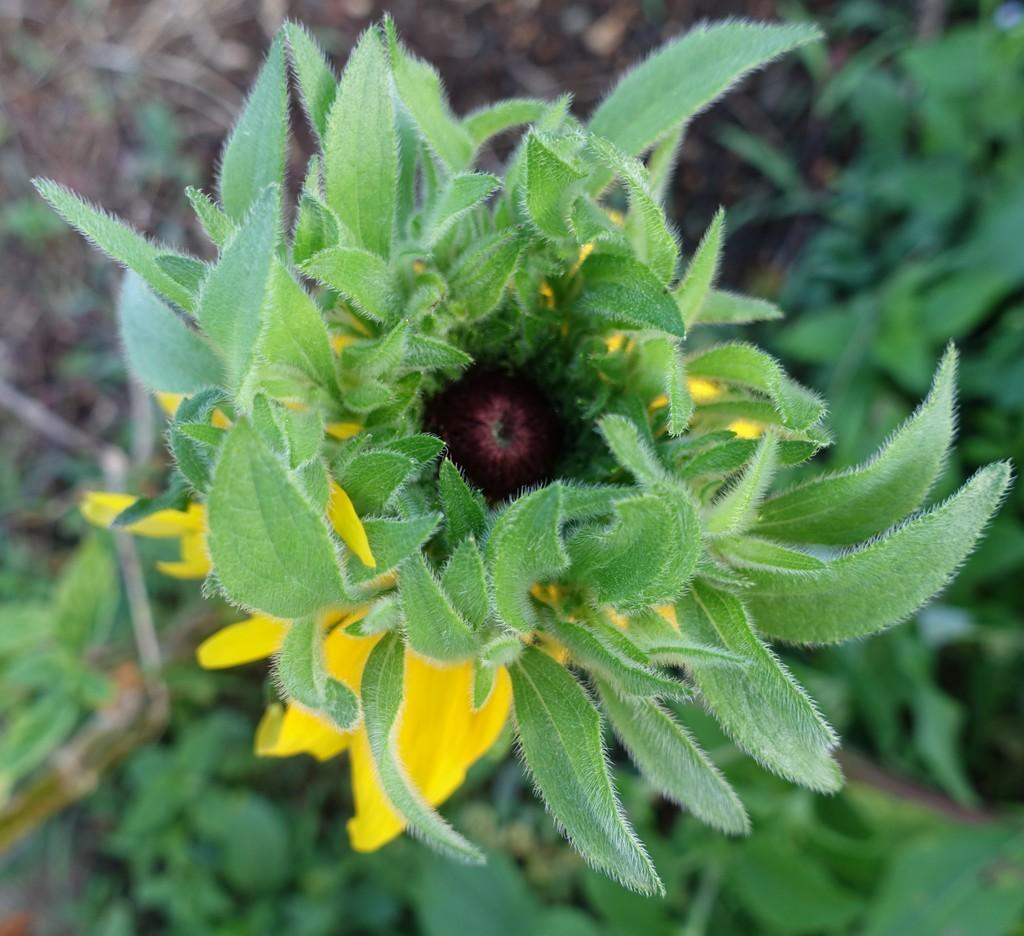What type of living organism is present in the image? There is a plant in the image. What specific features can be observed on the plant? The plant has flowers, and the flowers have yellow petals. What other parts of the plant are visible in the image? There are leaves visible in the image. What is visible at the top of the image? The ground is visible at the top of the image. What type of doll is sitting on the plant in the image? There is no doll present in the image; it features a plant with flowers and leaves. Can you describe the mist surrounding the plant in the image? There is no mist present in the image; the plant is surrounded by leaves and flowers. 